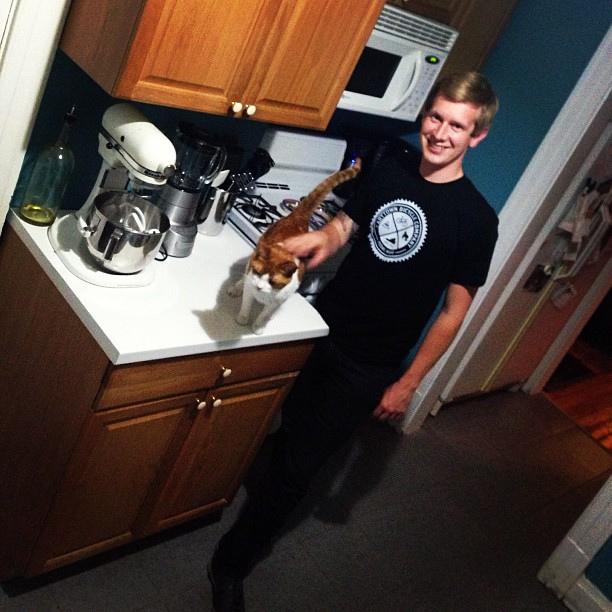What are these objects sitting on?
Keep it brief. Counter. What type of scene is this?
Be succinct. Kitchen. Is there a light on in another room?
Concise answer only. Yes. What room is the man in?
Short answer required. Kitchen. Is the floor carpeted or tiled?
Concise answer only. Tiled. What is the bus driver wearing?
Quick response, please. Tee shirt. Is the man wearing a hat?
Write a very short answer. No. 